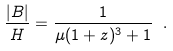<formula> <loc_0><loc_0><loc_500><loc_500>\frac { | B | } { H } = \frac { 1 } { \mu ( 1 + z ) ^ { 3 } + 1 } \ .</formula> 